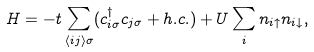Convert formula to latex. <formula><loc_0><loc_0><loc_500><loc_500>H = - t \sum _ { \langle i j \rangle \sigma } ( c ^ { \dagger } _ { i \sigma } c _ { j \sigma } + h . c . ) + U \sum _ { i } n _ { i \uparrow } n _ { i \downarrow } ,</formula> 